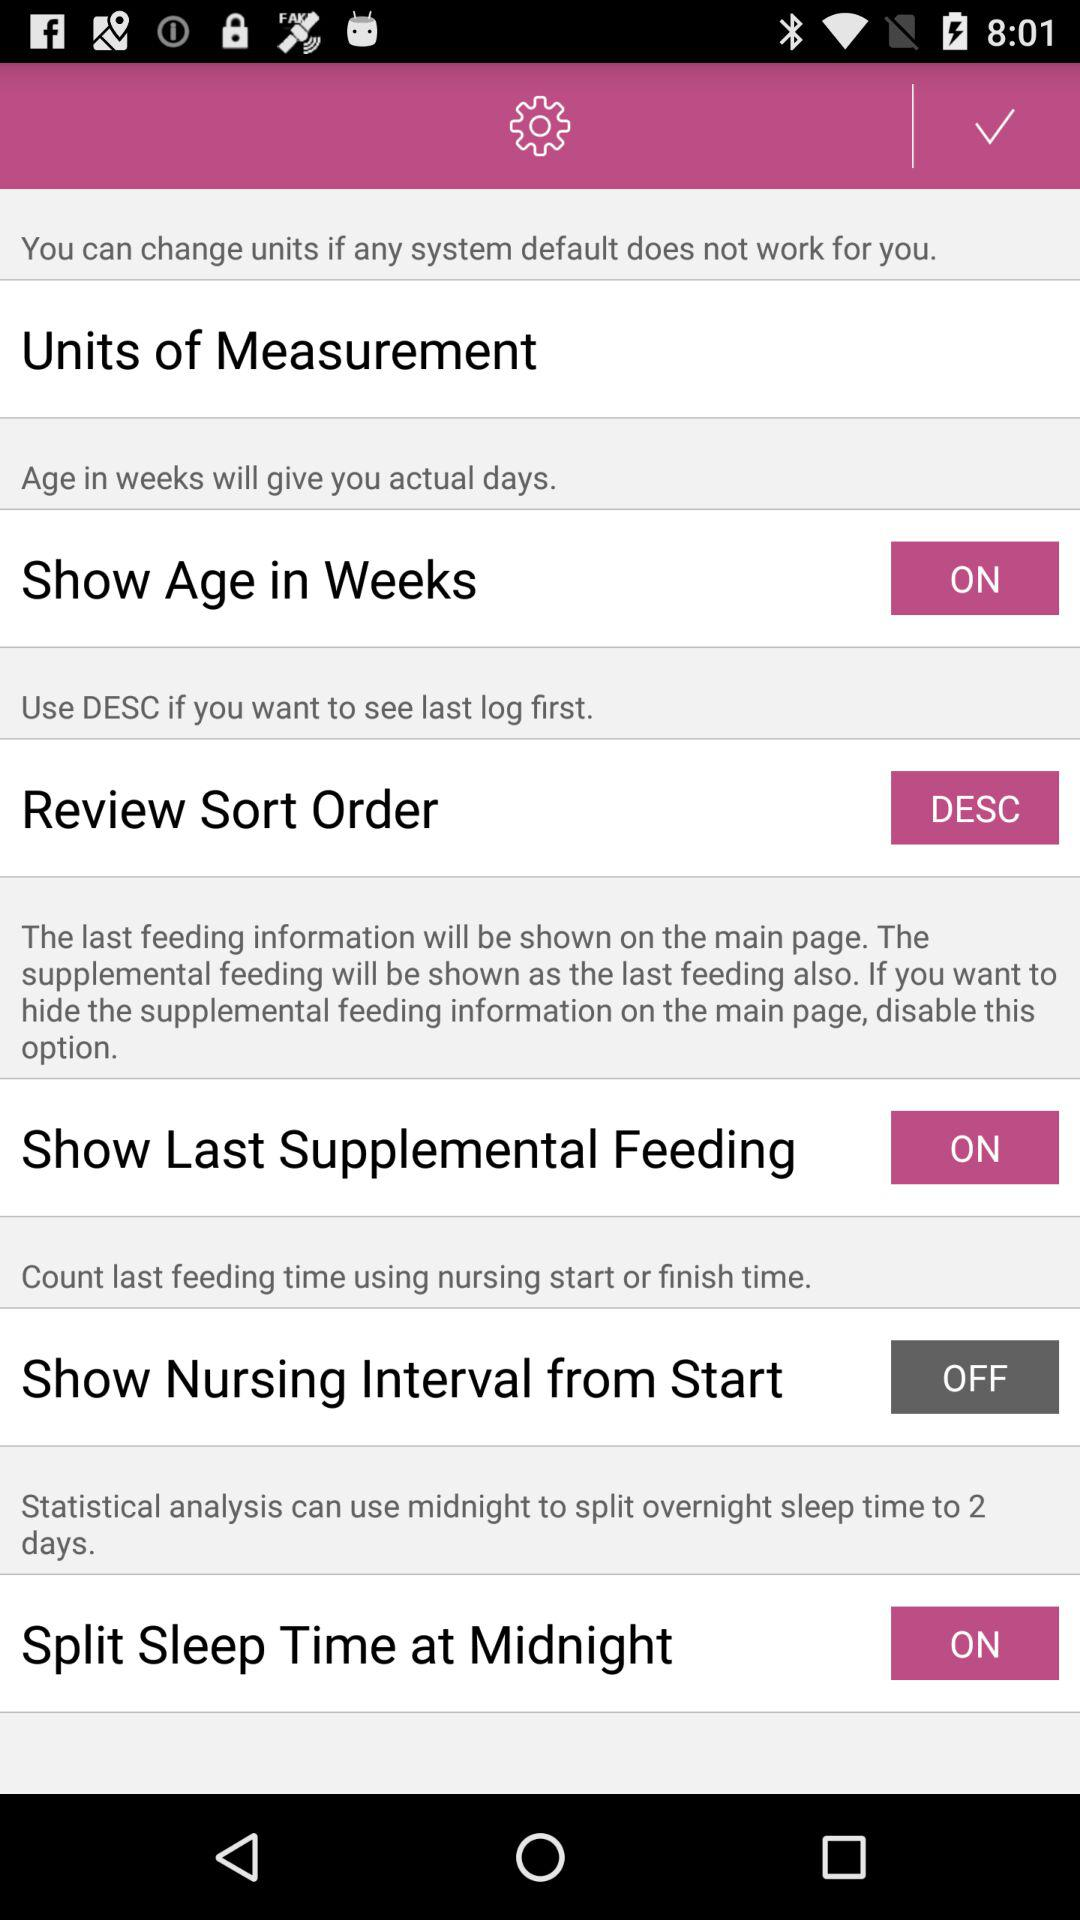What is the status of the "Show Age in Weeks"? The status is "on". 